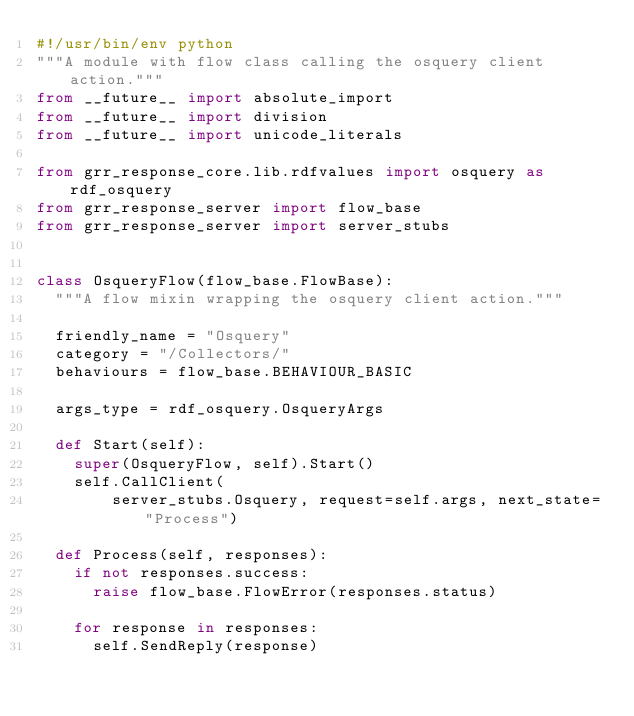<code> <loc_0><loc_0><loc_500><loc_500><_Python_>#!/usr/bin/env python
"""A module with flow class calling the osquery client action."""
from __future__ import absolute_import
from __future__ import division
from __future__ import unicode_literals

from grr_response_core.lib.rdfvalues import osquery as rdf_osquery
from grr_response_server import flow_base
from grr_response_server import server_stubs


class OsqueryFlow(flow_base.FlowBase):
  """A flow mixin wrapping the osquery client action."""

  friendly_name = "Osquery"
  category = "/Collectors/"
  behaviours = flow_base.BEHAVIOUR_BASIC

  args_type = rdf_osquery.OsqueryArgs

  def Start(self):
    super(OsqueryFlow, self).Start()
    self.CallClient(
        server_stubs.Osquery, request=self.args, next_state="Process")

  def Process(self, responses):
    if not responses.success:
      raise flow_base.FlowError(responses.status)

    for response in responses:
      self.SendReply(response)
</code> 